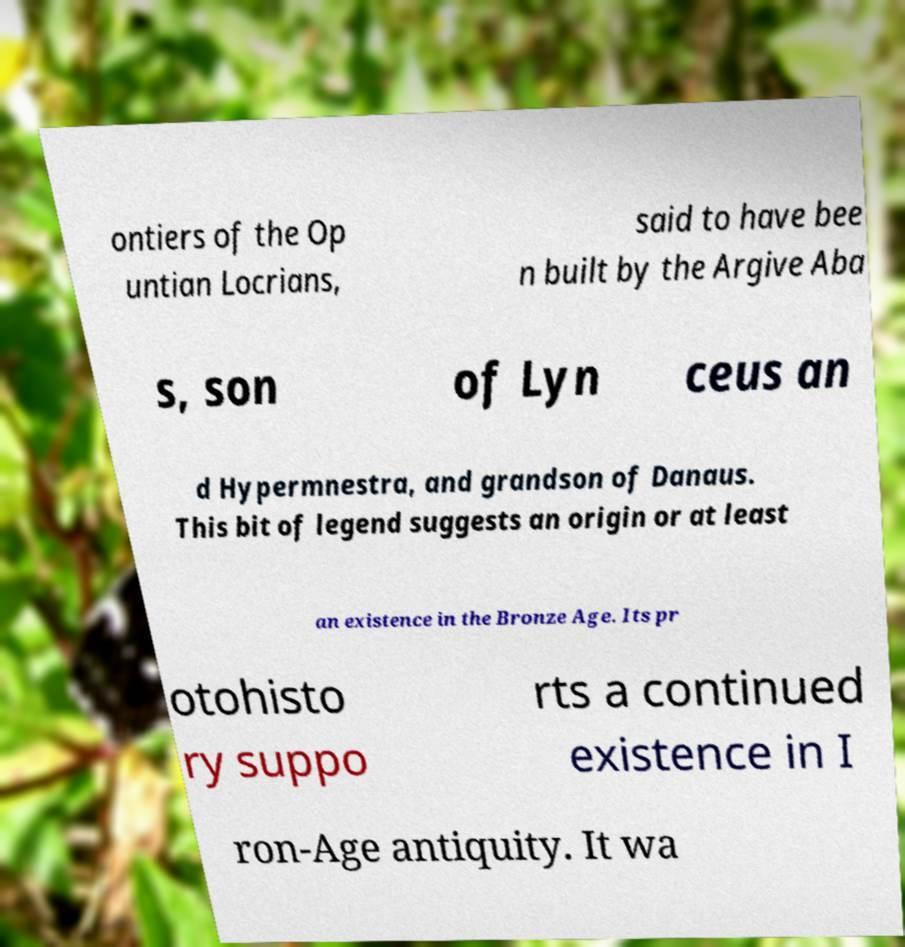There's text embedded in this image that I need extracted. Can you transcribe it verbatim? ontiers of the Op untian Locrians, said to have bee n built by the Argive Aba s, son of Lyn ceus an d Hypermnestra, and grandson of Danaus. This bit of legend suggests an origin or at least an existence in the Bronze Age. Its pr otohisto ry suppo rts a continued existence in I ron-Age antiquity. It wa 